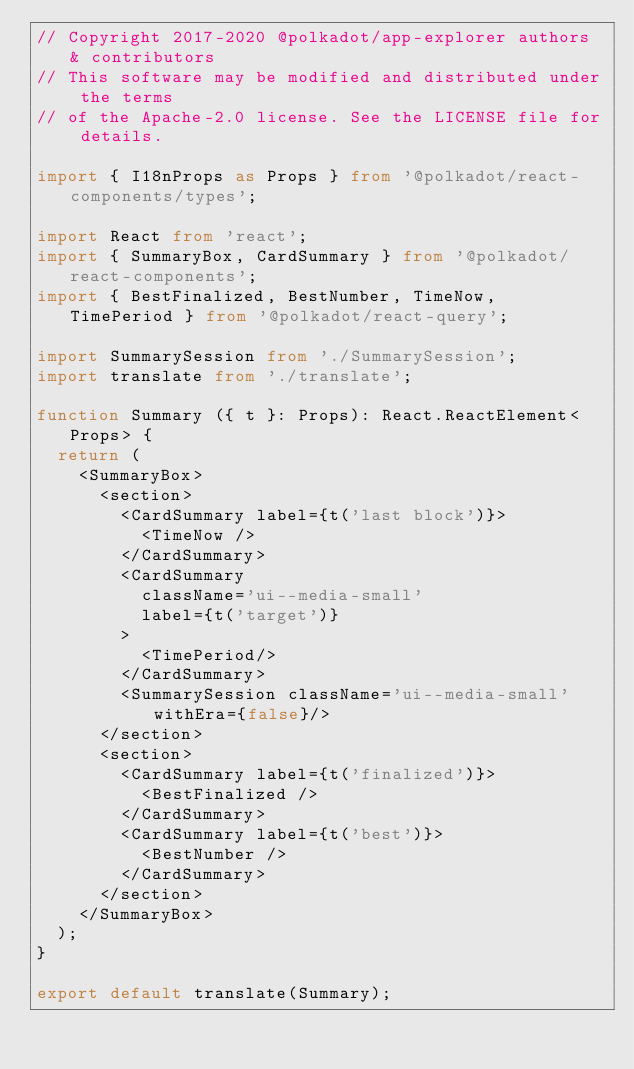Convert code to text. <code><loc_0><loc_0><loc_500><loc_500><_TypeScript_>// Copyright 2017-2020 @polkadot/app-explorer authors & contributors
// This software may be modified and distributed under the terms
// of the Apache-2.0 license. See the LICENSE file for details.

import { I18nProps as Props } from '@polkadot/react-components/types';

import React from 'react';
import { SummaryBox, CardSummary } from '@polkadot/react-components';
import { BestFinalized, BestNumber, TimeNow, TimePeriod } from '@polkadot/react-query';

import SummarySession from './SummarySession';
import translate from './translate';

function Summary ({ t }: Props): React.ReactElement<Props> {
  return (
    <SummaryBox>
      <section>
        <CardSummary label={t('last block')}>
          <TimeNow />
        </CardSummary>
        <CardSummary
          className='ui--media-small'
          label={t('target')}
        >
          <TimePeriod/>
        </CardSummary>
        <SummarySession className='ui--media-small' withEra={false}/>
      </section>
      <section>
        <CardSummary label={t('finalized')}>
          <BestFinalized />
        </CardSummary>
        <CardSummary label={t('best')}>
          <BestNumber />
        </CardSummary>
      </section>
    </SummaryBox>
  );
}

export default translate(Summary);
</code> 